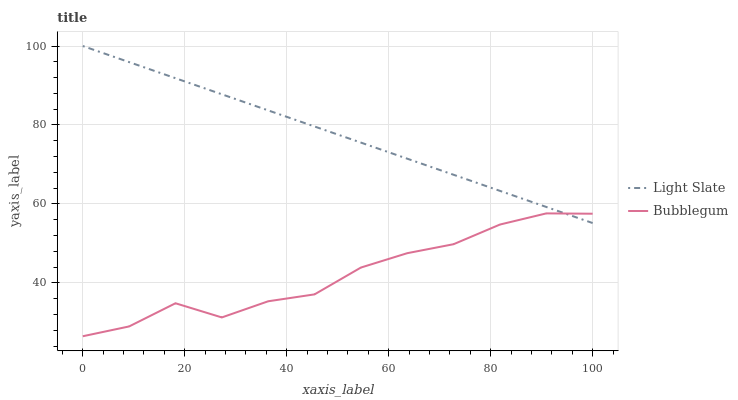Does Bubblegum have the minimum area under the curve?
Answer yes or no. Yes. Does Light Slate have the maximum area under the curve?
Answer yes or no. Yes. Does Bubblegum have the maximum area under the curve?
Answer yes or no. No. Is Light Slate the smoothest?
Answer yes or no. Yes. Is Bubblegum the roughest?
Answer yes or no. Yes. Is Bubblegum the smoothest?
Answer yes or no. No. Does Bubblegum have the lowest value?
Answer yes or no. Yes. Does Light Slate have the highest value?
Answer yes or no. Yes. Does Bubblegum have the highest value?
Answer yes or no. No. Does Light Slate intersect Bubblegum?
Answer yes or no. Yes. Is Light Slate less than Bubblegum?
Answer yes or no. No. Is Light Slate greater than Bubblegum?
Answer yes or no. No. 